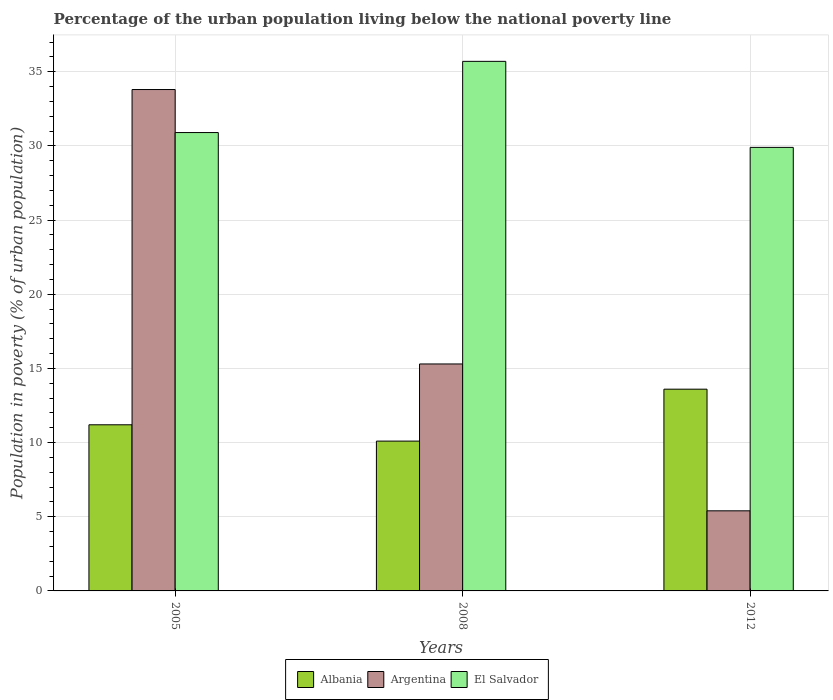Are the number of bars on each tick of the X-axis equal?
Offer a terse response. Yes. Across all years, what is the maximum percentage of the urban population living below the national poverty line in Albania?
Give a very brief answer. 13.6. Across all years, what is the minimum percentage of the urban population living below the national poverty line in El Salvador?
Make the answer very short. 29.9. In which year was the percentage of the urban population living below the national poverty line in El Salvador maximum?
Your answer should be very brief. 2008. What is the total percentage of the urban population living below the national poverty line in El Salvador in the graph?
Keep it short and to the point. 96.5. What is the difference between the percentage of the urban population living below the national poverty line in Argentina in 2005 and that in 2012?
Provide a succinct answer. 28.4. What is the difference between the percentage of the urban population living below the national poverty line in Albania in 2005 and the percentage of the urban population living below the national poverty line in Argentina in 2012?
Keep it short and to the point. 5.8. What is the average percentage of the urban population living below the national poverty line in El Salvador per year?
Ensure brevity in your answer.  32.17. In the year 2012, what is the difference between the percentage of the urban population living below the national poverty line in Albania and percentage of the urban population living below the national poverty line in El Salvador?
Your answer should be compact. -16.3. What is the ratio of the percentage of the urban population living below the national poverty line in El Salvador in 2005 to that in 2008?
Your answer should be very brief. 0.87. Is the percentage of the urban population living below the national poverty line in El Salvador in 2008 less than that in 2012?
Make the answer very short. No. Is the difference between the percentage of the urban population living below the national poverty line in Albania in 2005 and 2012 greater than the difference between the percentage of the urban population living below the national poverty line in El Salvador in 2005 and 2012?
Give a very brief answer. No. What is the difference between the highest and the second highest percentage of the urban population living below the national poverty line in Argentina?
Provide a succinct answer. 18.5. In how many years, is the percentage of the urban population living below the national poverty line in Albania greater than the average percentage of the urban population living below the national poverty line in Albania taken over all years?
Your answer should be compact. 1. Is the sum of the percentage of the urban population living below the national poverty line in Albania in 2008 and 2012 greater than the maximum percentage of the urban population living below the national poverty line in El Salvador across all years?
Make the answer very short. No. What does the 1st bar from the left in 2012 represents?
Offer a very short reply. Albania. What does the 1st bar from the right in 2008 represents?
Offer a very short reply. El Salvador. How many bars are there?
Your answer should be compact. 9. Are the values on the major ticks of Y-axis written in scientific E-notation?
Provide a short and direct response. No. Does the graph contain any zero values?
Provide a short and direct response. No. Does the graph contain grids?
Provide a succinct answer. Yes. What is the title of the graph?
Ensure brevity in your answer.  Percentage of the urban population living below the national poverty line. What is the label or title of the X-axis?
Make the answer very short. Years. What is the label or title of the Y-axis?
Offer a very short reply. Population in poverty (% of urban population). What is the Population in poverty (% of urban population) of Albania in 2005?
Offer a very short reply. 11.2. What is the Population in poverty (% of urban population) of Argentina in 2005?
Your answer should be compact. 33.8. What is the Population in poverty (% of urban population) in El Salvador in 2005?
Give a very brief answer. 30.9. What is the Population in poverty (% of urban population) of Albania in 2008?
Offer a very short reply. 10.1. What is the Population in poverty (% of urban population) of Argentina in 2008?
Keep it short and to the point. 15.3. What is the Population in poverty (% of urban population) in El Salvador in 2008?
Keep it short and to the point. 35.7. What is the Population in poverty (% of urban population) in El Salvador in 2012?
Make the answer very short. 29.9. Across all years, what is the maximum Population in poverty (% of urban population) of Albania?
Keep it short and to the point. 13.6. Across all years, what is the maximum Population in poverty (% of urban population) of Argentina?
Offer a terse response. 33.8. Across all years, what is the maximum Population in poverty (% of urban population) in El Salvador?
Provide a succinct answer. 35.7. Across all years, what is the minimum Population in poverty (% of urban population) in Albania?
Keep it short and to the point. 10.1. Across all years, what is the minimum Population in poverty (% of urban population) of El Salvador?
Ensure brevity in your answer.  29.9. What is the total Population in poverty (% of urban population) of Albania in the graph?
Provide a succinct answer. 34.9. What is the total Population in poverty (% of urban population) in Argentina in the graph?
Ensure brevity in your answer.  54.5. What is the total Population in poverty (% of urban population) of El Salvador in the graph?
Your answer should be compact. 96.5. What is the difference between the Population in poverty (% of urban population) of Albania in 2005 and that in 2008?
Give a very brief answer. 1.1. What is the difference between the Population in poverty (% of urban population) of Argentina in 2005 and that in 2008?
Provide a succinct answer. 18.5. What is the difference between the Population in poverty (% of urban population) in Argentina in 2005 and that in 2012?
Offer a terse response. 28.4. What is the difference between the Population in poverty (% of urban population) in Albania in 2008 and that in 2012?
Give a very brief answer. -3.5. What is the difference between the Population in poverty (% of urban population) in Albania in 2005 and the Population in poverty (% of urban population) in El Salvador in 2008?
Give a very brief answer. -24.5. What is the difference between the Population in poverty (% of urban population) in Albania in 2005 and the Population in poverty (% of urban population) in El Salvador in 2012?
Keep it short and to the point. -18.7. What is the difference between the Population in poverty (% of urban population) in Albania in 2008 and the Population in poverty (% of urban population) in El Salvador in 2012?
Provide a short and direct response. -19.8. What is the difference between the Population in poverty (% of urban population) of Argentina in 2008 and the Population in poverty (% of urban population) of El Salvador in 2012?
Ensure brevity in your answer.  -14.6. What is the average Population in poverty (% of urban population) of Albania per year?
Keep it short and to the point. 11.63. What is the average Population in poverty (% of urban population) in Argentina per year?
Offer a terse response. 18.17. What is the average Population in poverty (% of urban population) in El Salvador per year?
Your answer should be very brief. 32.17. In the year 2005, what is the difference between the Population in poverty (% of urban population) of Albania and Population in poverty (% of urban population) of Argentina?
Ensure brevity in your answer.  -22.6. In the year 2005, what is the difference between the Population in poverty (% of urban population) of Albania and Population in poverty (% of urban population) of El Salvador?
Your answer should be compact. -19.7. In the year 2005, what is the difference between the Population in poverty (% of urban population) in Argentina and Population in poverty (% of urban population) in El Salvador?
Keep it short and to the point. 2.9. In the year 2008, what is the difference between the Population in poverty (% of urban population) in Albania and Population in poverty (% of urban population) in Argentina?
Offer a terse response. -5.2. In the year 2008, what is the difference between the Population in poverty (% of urban population) in Albania and Population in poverty (% of urban population) in El Salvador?
Make the answer very short. -25.6. In the year 2008, what is the difference between the Population in poverty (% of urban population) of Argentina and Population in poverty (% of urban population) of El Salvador?
Give a very brief answer. -20.4. In the year 2012, what is the difference between the Population in poverty (% of urban population) in Albania and Population in poverty (% of urban population) in Argentina?
Your response must be concise. 8.2. In the year 2012, what is the difference between the Population in poverty (% of urban population) in Albania and Population in poverty (% of urban population) in El Salvador?
Provide a short and direct response. -16.3. In the year 2012, what is the difference between the Population in poverty (% of urban population) of Argentina and Population in poverty (% of urban population) of El Salvador?
Give a very brief answer. -24.5. What is the ratio of the Population in poverty (% of urban population) in Albania in 2005 to that in 2008?
Your response must be concise. 1.11. What is the ratio of the Population in poverty (% of urban population) in Argentina in 2005 to that in 2008?
Offer a very short reply. 2.21. What is the ratio of the Population in poverty (% of urban population) in El Salvador in 2005 to that in 2008?
Your answer should be compact. 0.87. What is the ratio of the Population in poverty (% of urban population) in Albania in 2005 to that in 2012?
Provide a short and direct response. 0.82. What is the ratio of the Population in poverty (% of urban population) of Argentina in 2005 to that in 2012?
Provide a short and direct response. 6.26. What is the ratio of the Population in poverty (% of urban population) of El Salvador in 2005 to that in 2012?
Your answer should be compact. 1.03. What is the ratio of the Population in poverty (% of urban population) in Albania in 2008 to that in 2012?
Offer a very short reply. 0.74. What is the ratio of the Population in poverty (% of urban population) of Argentina in 2008 to that in 2012?
Offer a terse response. 2.83. What is the ratio of the Population in poverty (% of urban population) in El Salvador in 2008 to that in 2012?
Provide a succinct answer. 1.19. What is the difference between the highest and the second highest Population in poverty (% of urban population) of Albania?
Offer a terse response. 2.4. What is the difference between the highest and the second highest Population in poverty (% of urban population) in Argentina?
Your answer should be compact. 18.5. What is the difference between the highest and the second highest Population in poverty (% of urban population) in El Salvador?
Provide a succinct answer. 4.8. What is the difference between the highest and the lowest Population in poverty (% of urban population) in Argentina?
Offer a terse response. 28.4. What is the difference between the highest and the lowest Population in poverty (% of urban population) of El Salvador?
Provide a short and direct response. 5.8. 